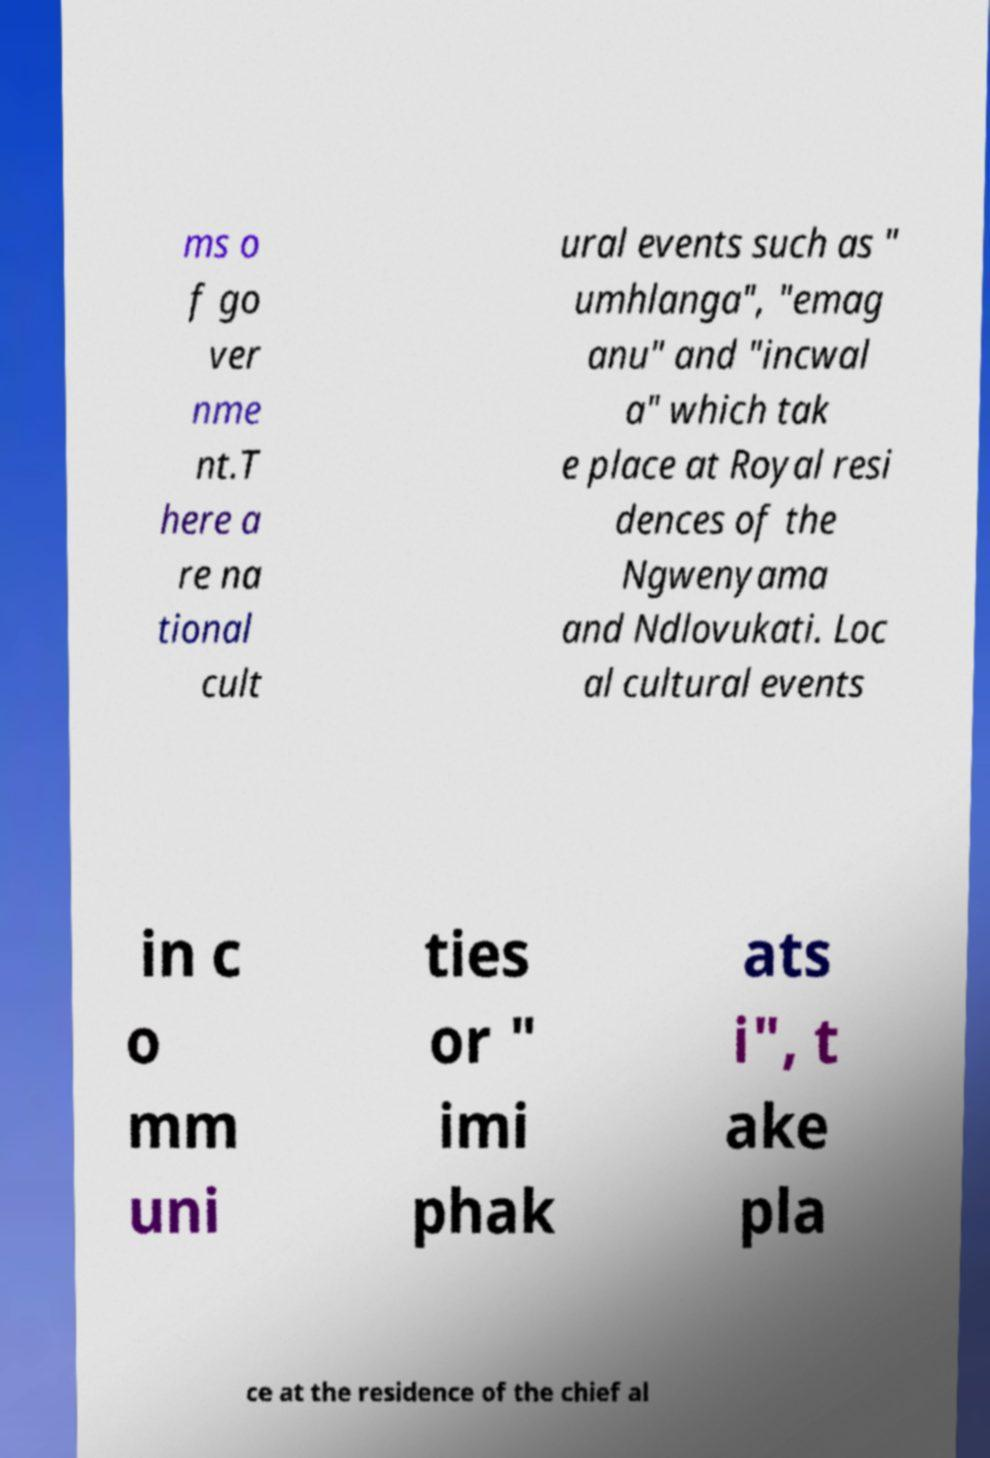Could you assist in decoding the text presented in this image and type it out clearly? ms o f go ver nme nt.T here a re na tional cult ural events such as " umhlanga", "emag anu" and "incwal a" which tak e place at Royal resi dences of the Ngwenyama and Ndlovukati. Loc al cultural events in c o mm uni ties or " imi phak ats i", t ake pla ce at the residence of the chief al 